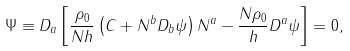Convert formula to latex. <formula><loc_0><loc_0><loc_500><loc_500>\Psi \equiv D _ { a } \left [ \frac { \rho _ { 0 } } { N h } \left ( C + N ^ { b } D _ { b } \psi \right ) N ^ { a } - \frac { N \rho _ { 0 } } { h } D ^ { a } \psi \right ] = 0 ,</formula> 